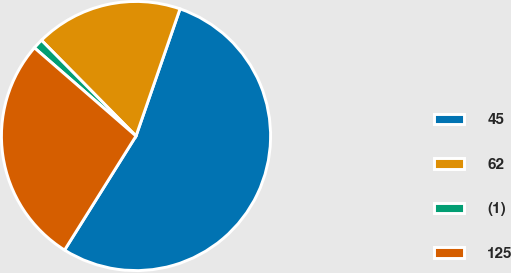Convert chart to OTSL. <chart><loc_0><loc_0><loc_500><loc_500><pie_chart><fcel>45<fcel>62<fcel>(1)<fcel>125<nl><fcel>53.6%<fcel>17.7%<fcel>1.22%<fcel>27.47%<nl></chart> 